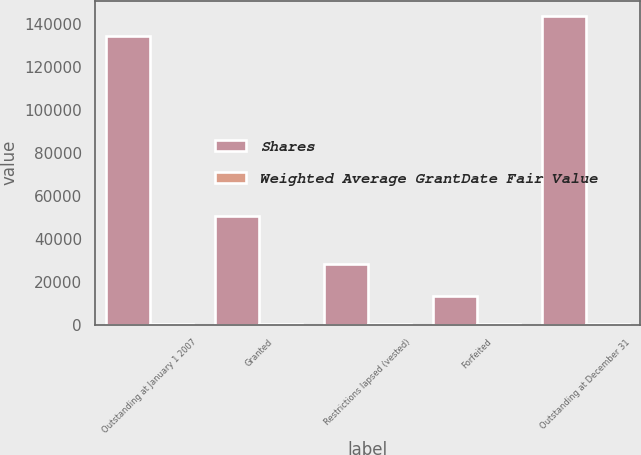Convert chart to OTSL. <chart><loc_0><loc_0><loc_500><loc_500><stacked_bar_chart><ecel><fcel>Outstanding at January 1 2007<fcel>Granted<fcel>Restrictions lapsed (vested)<fcel>Forfeited<fcel>Outstanding at December 31<nl><fcel>Shares<fcel>134378<fcel>50509<fcel>28044<fcel>13234<fcel>143609<nl><fcel>Weighted Average GrantDate Fair Value<fcel>15.27<fcel>49.21<fcel>16.96<fcel>14.83<fcel>26.92<nl></chart> 